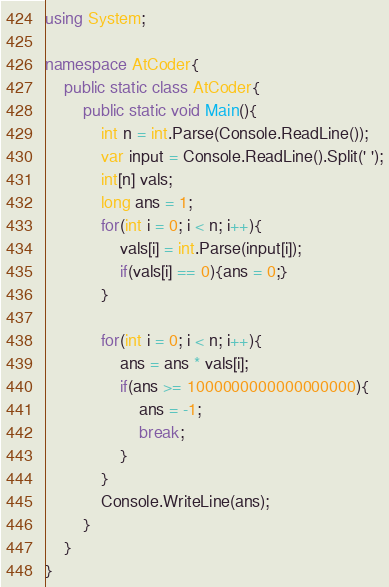<code> <loc_0><loc_0><loc_500><loc_500><_C#_>using System;

namespace AtCoder{
    public static class AtCoder{
        public static void Main(){
            int n = int.Parse(Console.ReadLine());
            var input = Console.ReadLine().Split(' ');
            int[n] vals;
            long ans = 1;
            for(int i = 0; i < n; i++){
                vals[i] = int.Parse(input[i]);
                if(vals[i] == 0){ans = 0;}
            }

            for(int i = 0; i < n; i++){
                ans = ans * vals[i];
                if(ans >= 1000000000000000000){
                    ans = -1;
                    break;
                }
            }
            Console.WriteLine(ans);
        }
    }
}</code> 